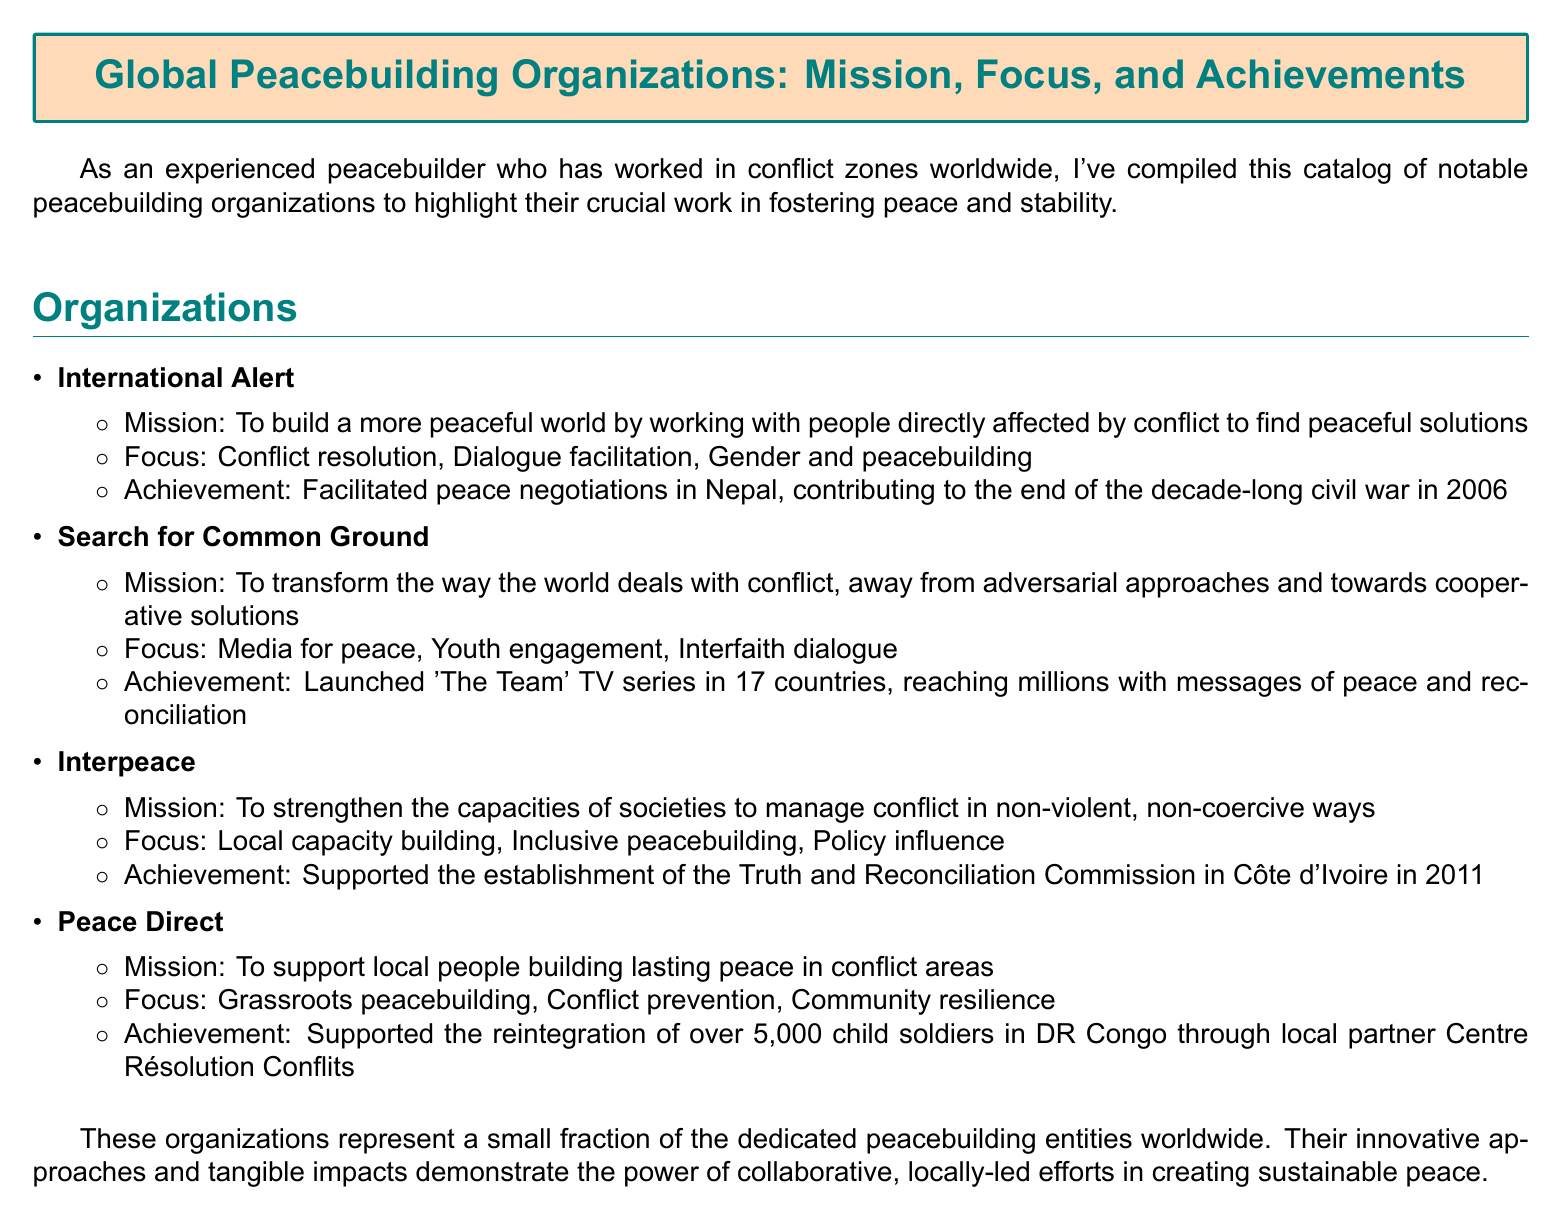What is the mission of International Alert? The mission of International Alert is to build a more peaceful world by working with people directly affected by conflict to find peaceful solutions.
Answer: To build a more peaceful world What focus area does Search for Common Ground emphasize? Search for Common Ground emphasizes media for peace as one of its focus areas.
Answer: Media for peace What notable achievement is attributed to Interpeace? The achievement attributed to Interpeace is supporting the establishment of the Truth and Reconciliation Commission in Côte d'Ivoire in 2011.
Answer: Supported the establishment of the Truth and Reconciliation Commission in Côte d'Ivoire in 2011 How many child soldiers were reintegrated with the help of Peace Direct? Peace Direct supported the reintegration of over 5,000 child soldiers in DR Congo.
Answer: Over 5,000 What is the main focus of Peace Direct's work? The main focus of Peace Direct's work is grassroots peacebuilding.
Answer: Grassroots peacebuilding Which organization facilitated peace negotiations in Nepal? The organization that facilitated peace negotiations in Nepal is International Alert.
Answer: International Alert What is the main approach that Search for Common Ground promotes for conflict resolution? Search for Common Ground promotes cooperative solutions for conflict resolution.
Answer: Cooperative solutions How many countries launched 'The Team' TV series? 'The Team' TV series was launched in 17 countries.
Answer: 17 